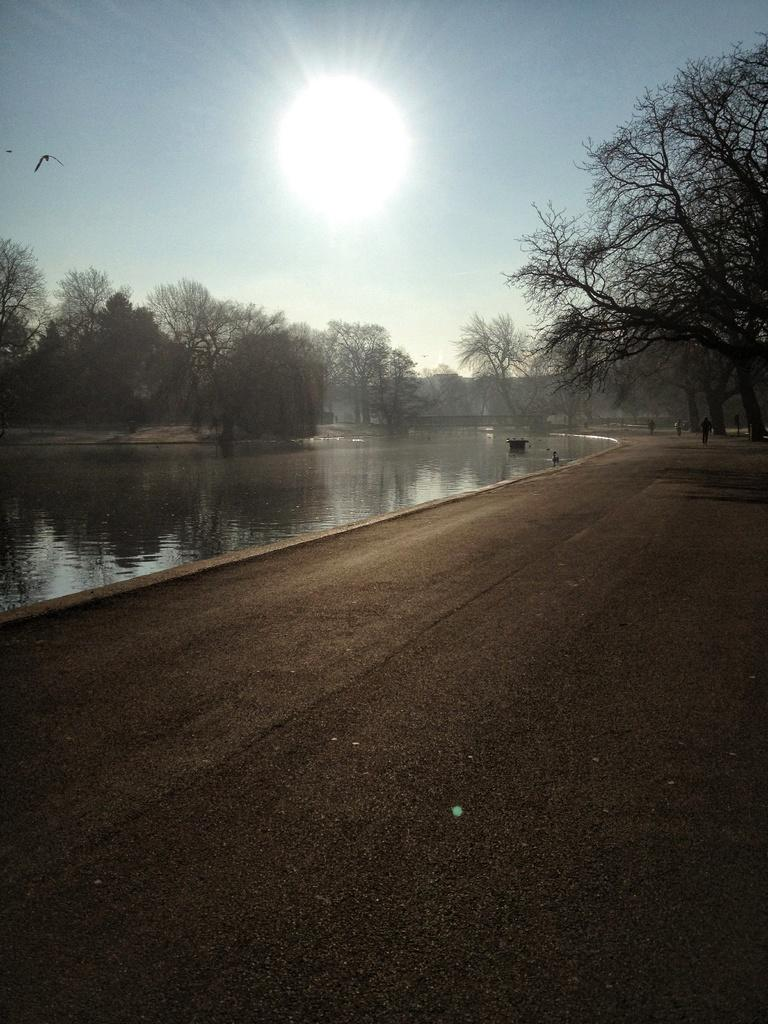What can be seen in the sky in the image? The sky is visible in the image, and the sun is also visible. What type of natural vegetation is present in the image? There are trees in the image. What is the water body in the image? There is a water body in the image, but its specific type is not mentioned. Who or what is present in the image along with the natural elements? There are people in the image. What type of man-made structure is visible in the image? There is a road in the image. How many pizzas are being delivered on bikes in the image? There are no bikes or pizzas present in the image. What type of rub is being used to clean the water body in the image? There is no rub or cleaning activity depicted in the image. 